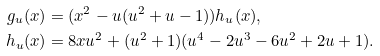<formula> <loc_0><loc_0><loc_500><loc_500>g _ { u } ( x ) & = ( x ^ { 2 } - u ( u ^ { 2 } + u - 1 ) ) h _ { u } ( x ) , \\ h _ { u } ( x ) & = 8 x u ^ { 2 } + ( u ^ { 2 } + 1 ) ( u ^ { 4 } - 2 u ^ { 3 } - 6 u ^ { 2 } + 2 u + 1 ) .</formula> 